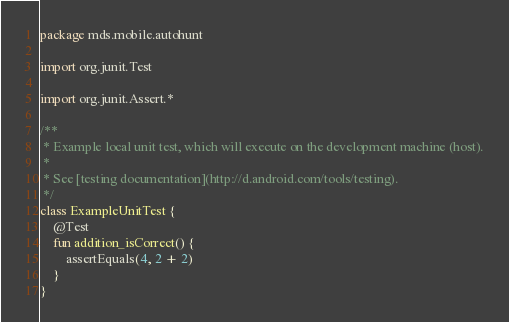Convert code to text. <code><loc_0><loc_0><loc_500><loc_500><_Kotlin_>package mds.mobile.autohunt

import org.junit.Test

import org.junit.Assert.*

/**
 * Example local unit test, which will execute on the development machine (host).
 *
 * See [testing documentation](http://d.android.com/tools/testing).
 */
class ExampleUnitTest {
    @Test
    fun addition_isCorrect() {
        assertEquals(4, 2 + 2)
    }
}
</code> 